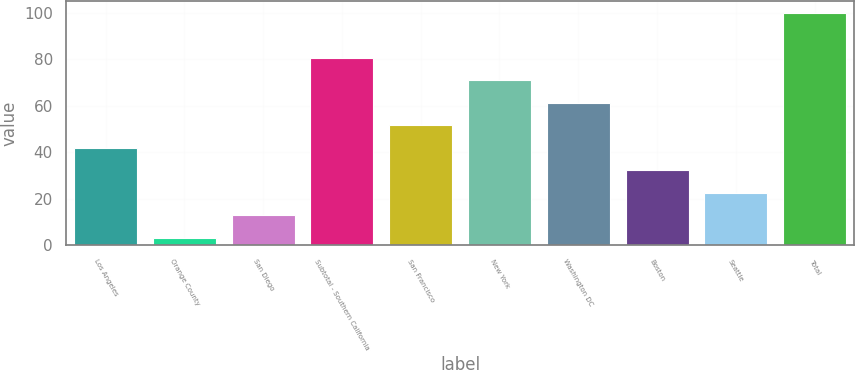Convert chart. <chart><loc_0><loc_0><loc_500><loc_500><bar_chart><fcel>Los Angeles<fcel>Orange County<fcel>San Diego<fcel>Subtotal - Southern California<fcel>San Francisco<fcel>New York<fcel>Washington DC<fcel>Boston<fcel>Seattle<fcel>Total<nl><fcel>41.86<fcel>3.1<fcel>12.79<fcel>80.62<fcel>51.55<fcel>70.93<fcel>61.24<fcel>32.17<fcel>22.48<fcel>100<nl></chart> 